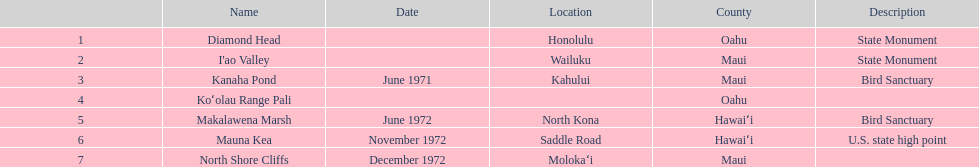In maui, what is the total count of landmarks present? 3. 